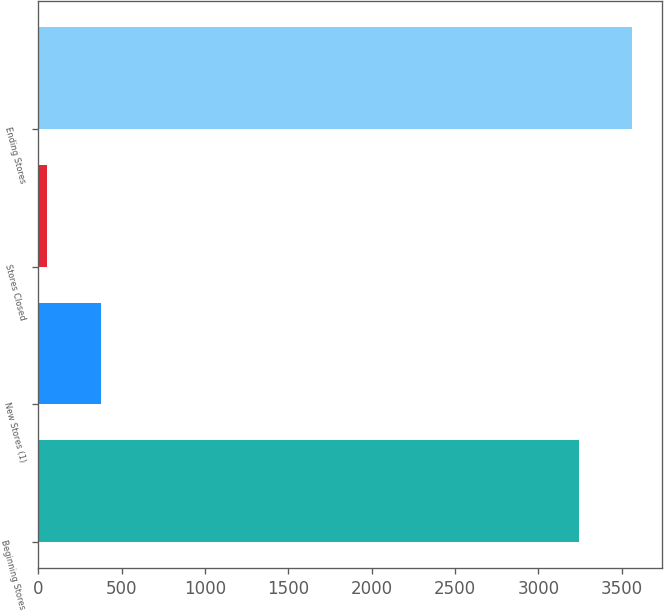Convert chart. <chart><loc_0><loc_0><loc_500><loc_500><bar_chart><fcel>Beginning Stores<fcel>New Stores (1)<fcel>Stores Closed<fcel>Ending Stores<nl><fcel>3243<fcel>375<fcel>54<fcel>3564<nl></chart> 